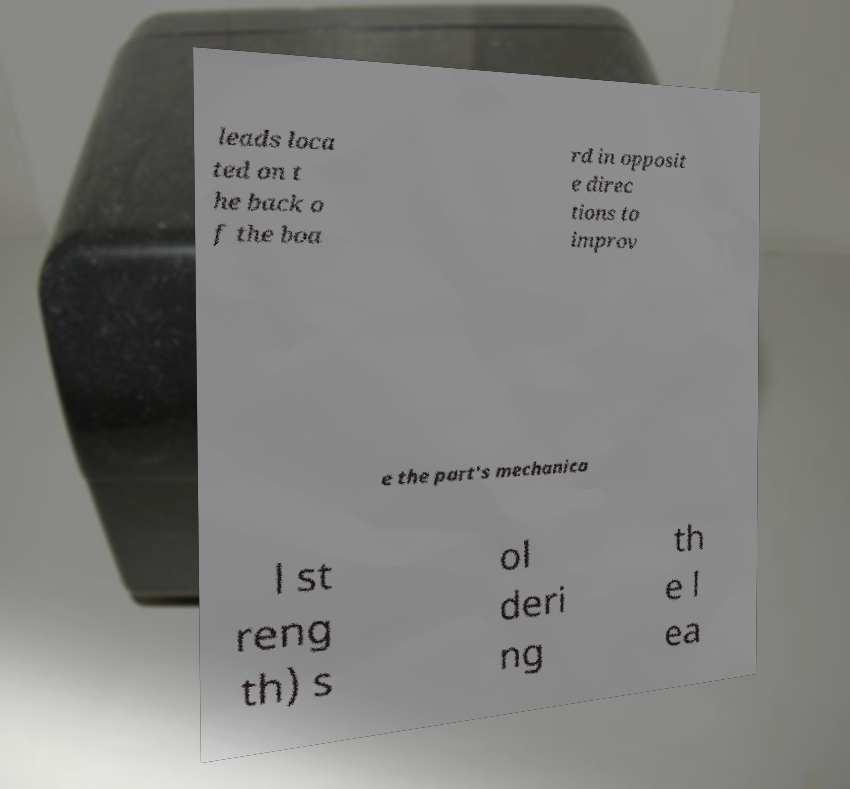Please identify and transcribe the text found in this image. leads loca ted on t he back o f the boa rd in opposit e direc tions to improv e the part's mechanica l st reng th) s ol deri ng th e l ea 